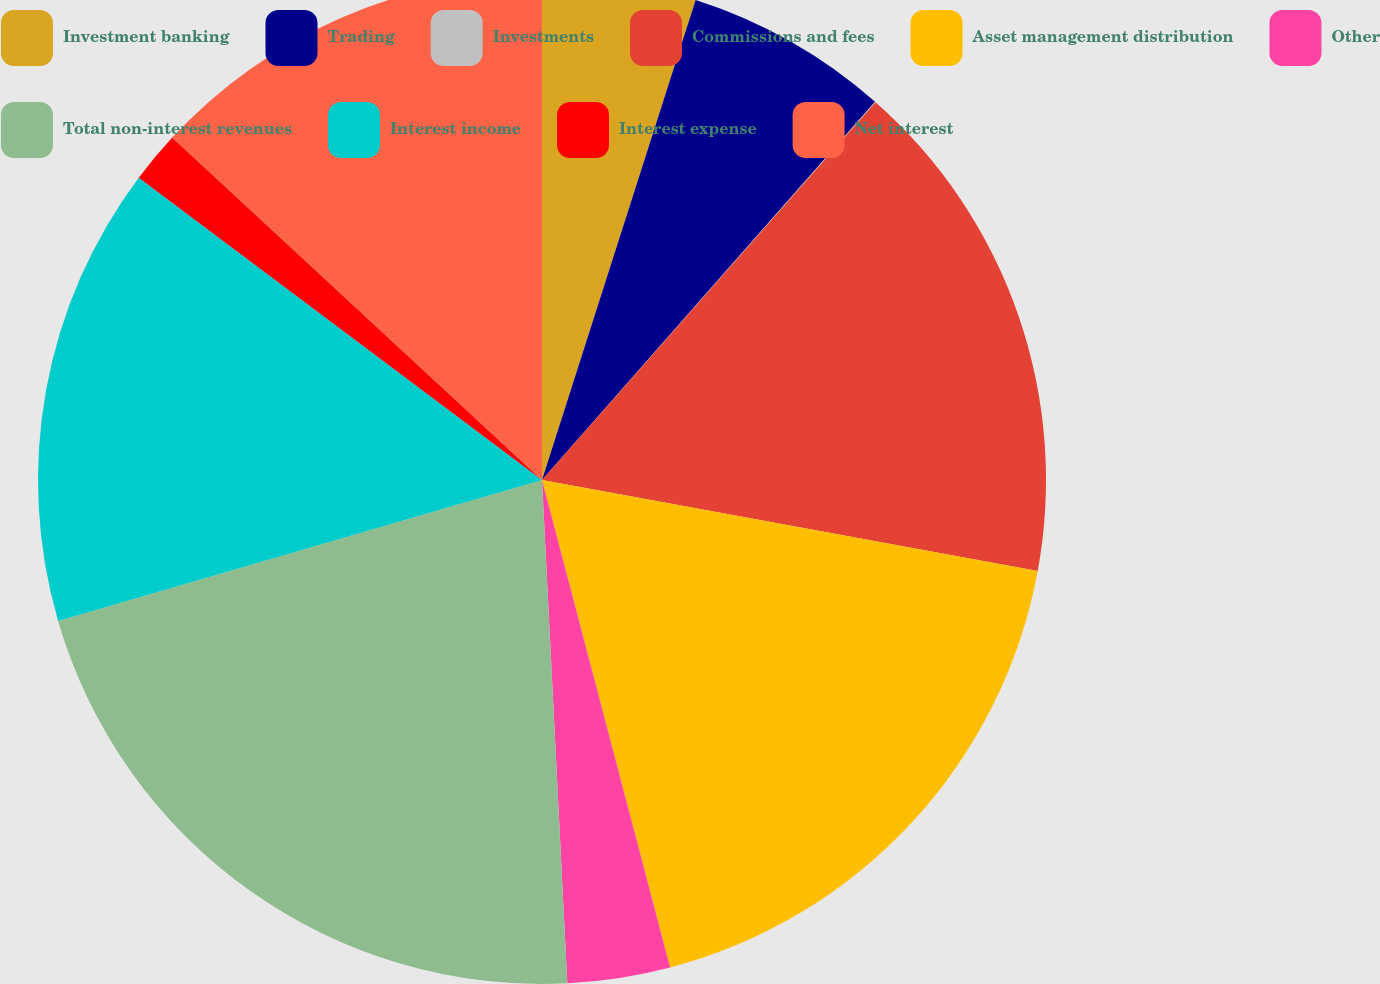Convert chart to OTSL. <chart><loc_0><loc_0><loc_500><loc_500><pie_chart><fcel>Investment banking<fcel>Trading<fcel>Investments<fcel>Commissions and fees<fcel>Asset management distribution<fcel>Other<fcel>Total non-interest revenues<fcel>Interest income<fcel>Interest expense<fcel>Net interest<nl><fcel>4.93%<fcel>6.56%<fcel>0.02%<fcel>16.38%<fcel>18.02%<fcel>3.29%<fcel>21.29%<fcel>14.75%<fcel>1.65%<fcel>13.11%<nl></chart> 